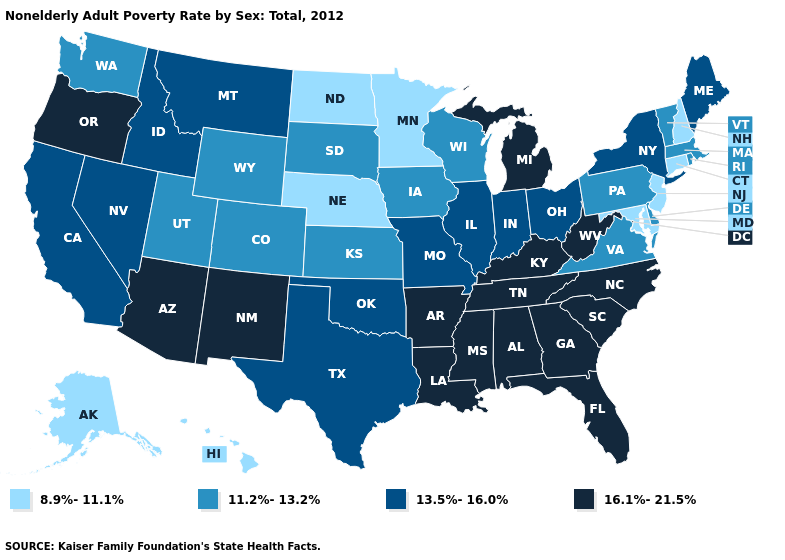What is the lowest value in the MidWest?
Concise answer only. 8.9%-11.1%. Among the states that border New Jersey , does Pennsylvania have the highest value?
Concise answer only. No. Which states have the lowest value in the USA?
Keep it brief. Alaska, Connecticut, Hawaii, Maryland, Minnesota, Nebraska, New Hampshire, New Jersey, North Dakota. How many symbols are there in the legend?
Concise answer only. 4. Name the states that have a value in the range 13.5%-16.0%?
Concise answer only. California, Idaho, Illinois, Indiana, Maine, Missouri, Montana, Nevada, New York, Ohio, Oklahoma, Texas. Does the map have missing data?
Answer briefly. No. What is the value of Minnesota?
Be succinct. 8.9%-11.1%. What is the lowest value in the USA?
Be succinct. 8.9%-11.1%. Does the map have missing data?
Answer briefly. No. What is the value of North Carolina?
Concise answer only. 16.1%-21.5%. Name the states that have a value in the range 16.1%-21.5%?
Quick response, please. Alabama, Arizona, Arkansas, Florida, Georgia, Kentucky, Louisiana, Michigan, Mississippi, New Mexico, North Carolina, Oregon, South Carolina, Tennessee, West Virginia. Does the first symbol in the legend represent the smallest category?
Answer briefly. Yes. Which states hav the highest value in the West?
Short answer required. Arizona, New Mexico, Oregon. Does the map have missing data?
Answer briefly. No. What is the highest value in states that border Vermont?
Be succinct. 13.5%-16.0%. 